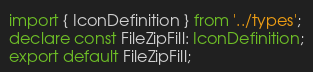Convert code to text. <code><loc_0><loc_0><loc_500><loc_500><_TypeScript_>import { IconDefinition } from '../types';
declare const FileZipFill: IconDefinition;
export default FileZipFill;
</code> 